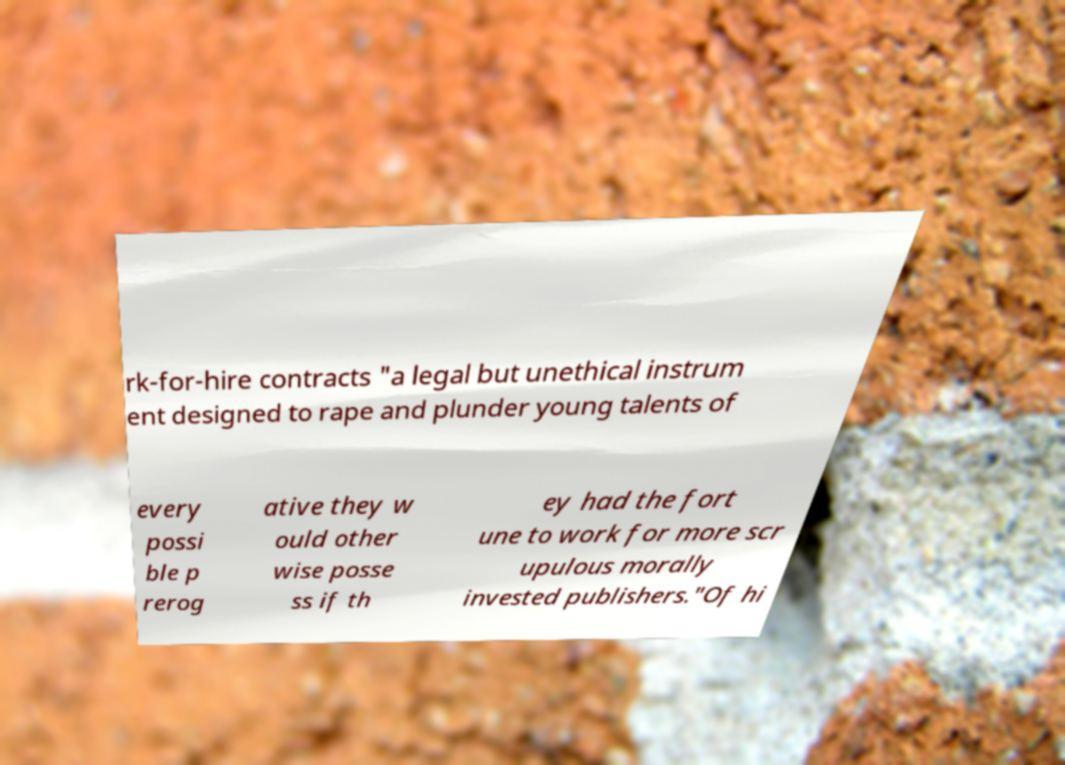There's text embedded in this image that I need extracted. Can you transcribe it verbatim? rk-for-hire contracts "a legal but unethical instrum ent designed to rape and plunder young talents of every possi ble p rerog ative they w ould other wise posse ss if th ey had the fort une to work for more scr upulous morally invested publishers."Of hi 